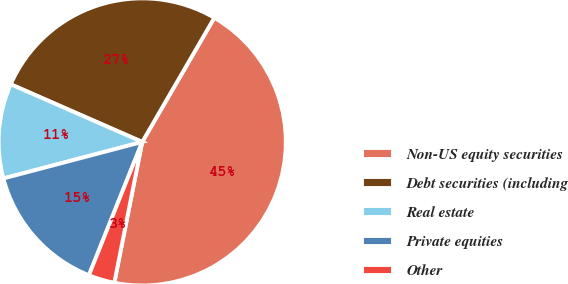<chart> <loc_0><loc_0><loc_500><loc_500><pie_chart><fcel>Non-US equity securities<fcel>Debt securities (including<fcel>Real estate<fcel>Private equities<fcel>Other<nl><fcel>44.75%<fcel>26.8%<fcel>10.67%<fcel>14.85%<fcel>2.94%<nl></chart> 